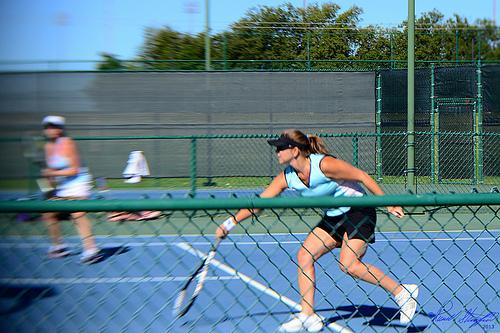Write a brief account of the main focus of the image. The image captures a moment in a tennis match where a female player in a black visor swings her racket on a blue court. Detail what the tennis player in the image is doing. In the image, a female tennis player is intensely focused on the game as she swiftly swings her racket to strike the ball. Provide a simple explanation of the significant action in the image. A woman in a black visor is playing tennis on a blue court, holding her racket ready to swing. Write a sentence describing the main action in the image. A female tennis player is preparing to hit the ball with her tennis racket on a blue court. What is the most prominent element in the image? A woman wearing a black visor and holding a tennis racket stands out as the main focus of the image. Write a concise sentence about the main subject in the photo. The image shows a female tennis player in action, wearing a black visor and holding a racket on a blue court. Mention the primary activity taking place in the image. A woman wearing a black visor is actively swinging her tennis racket during a game. Elaborate on the attire of the main subject in the image. A woman clad in a light blue tank top, black shorts, and a black visor is playing tennis, swinging her racket skillfully. Provide a brief description of the scene in the image. A female tennis player in a black visor and shorts is swinging her racket on a blue tennis court, surrounded by a green chainlink fence. Describe the position of the person in the picture and what they're doing. A female tennis player, positioned at the net, is swinging her racket to hit the ball in a tennis match. Identify the purple and white striped top worn by a woman in the foreground. The woman's top is described as a light blue and white top, not purple and white striped. Observe the cute dog sitting near the green chain link fence. There is no mention of a dog in the image, so there's no dog to observe. How many tennis balls are lying on the blue tennis court? There is no mention of any tennis ball on the court, making it impossible to count them. Is the woman in the center swinging a green tennis racket? The tennis racket is black and white, not green. Observe the red chain link fence surrounding the courts. The chain link fence is green, not red. Do you see the brown lighting pole near the tennis court? The lighting pole is green, not brown. Pay attention to the children playing doubles tennis. No, it's not mentioned in the image. Describe the interaction between the kids playing in the background. There is no mention of kids in the image, so it's impossible to describe their interactions. Count the number of tennis rackets with red strings in the image. There are no tennis rackets mentioned with red strings, so there are none to count. Find a man wearing a red cap and jumping to hit the tennis ball. There is no man mentioned in the image, no red cap, and no jumping action described. Appreciate the beautiful sunset in the clear cloudy blue sky. The sky is described as "clear cloudless blue sky," which implies no clouds and therefore no sunset. Find the orange trees with yellow leaves near the fence. The trees are described as "tall trees with green leaves," not orange trees with yellow leaves. 